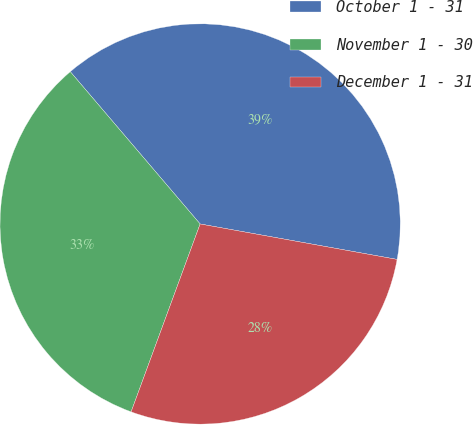Convert chart to OTSL. <chart><loc_0><loc_0><loc_500><loc_500><pie_chart><fcel>October 1 - 31<fcel>November 1 - 30<fcel>December 1 - 31<nl><fcel>39.07%<fcel>33.16%<fcel>27.77%<nl></chart> 